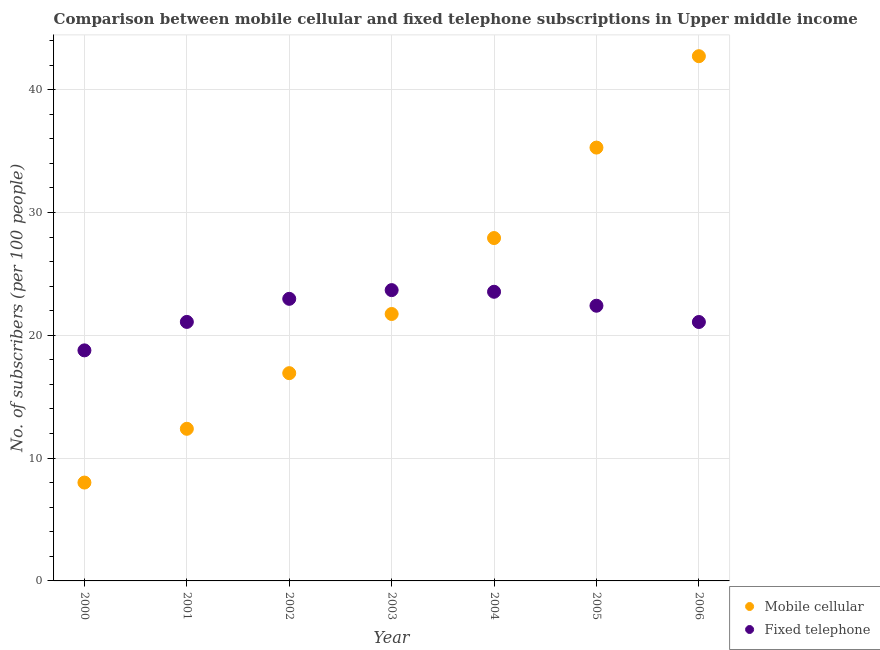How many different coloured dotlines are there?
Offer a terse response. 2. What is the number of mobile cellular subscribers in 2002?
Give a very brief answer. 16.92. Across all years, what is the maximum number of mobile cellular subscribers?
Keep it short and to the point. 42.73. Across all years, what is the minimum number of fixed telephone subscribers?
Give a very brief answer. 18.77. What is the total number of mobile cellular subscribers in the graph?
Provide a succinct answer. 164.99. What is the difference between the number of fixed telephone subscribers in 2003 and that in 2005?
Keep it short and to the point. 1.27. What is the difference between the number of fixed telephone subscribers in 2003 and the number of mobile cellular subscribers in 2000?
Provide a short and direct response. 15.67. What is the average number of fixed telephone subscribers per year?
Provide a succinct answer. 21.94. In the year 2000, what is the difference between the number of fixed telephone subscribers and number of mobile cellular subscribers?
Provide a succinct answer. 10.76. What is the ratio of the number of mobile cellular subscribers in 2001 to that in 2006?
Ensure brevity in your answer.  0.29. Is the number of fixed telephone subscribers in 2003 less than that in 2005?
Your response must be concise. No. What is the difference between the highest and the second highest number of fixed telephone subscribers?
Ensure brevity in your answer.  0.13. What is the difference between the highest and the lowest number of mobile cellular subscribers?
Offer a terse response. 34.72. Does the number of fixed telephone subscribers monotonically increase over the years?
Offer a very short reply. No. Is the number of mobile cellular subscribers strictly less than the number of fixed telephone subscribers over the years?
Keep it short and to the point. No. How many dotlines are there?
Your response must be concise. 2. What is the title of the graph?
Offer a very short reply. Comparison between mobile cellular and fixed telephone subscriptions in Upper middle income. Does "Under-five" appear as one of the legend labels in the graph?
Keep it short and to the point. No. What is the label or title of the X-axis?
Offer a terse response. Year. What is the label or title of the Y-axis?
Give a very brief answer. No. of subscribers (per 100 people). What is the No. of subscribers (per 100 people) in Mobile cellular in 2000?
Provide a short and direct response. 8.01. What is the No. of subscribers (per 100 people) of Fixed telephone in 2000?
Ensure brevity in your answer.  18.77. What is the No. of subscribers (per 100 people) in Mobile cellular in 2001?
Keep it short and to the point. 12.39. What is the No. of subscribers (per 100 people) in Fixed telephone in 2001?
Keep it short and to the point. 21.09. What is the No. of subscribers (per 100 people) of Mobile cellular in 2002?
Ensure brevity in your answer.  16.92. What is the No. of subscribers (per 100 people) in Fixed telephone in 2002?
Make the answer very short. 22.97. What is the No. of subscribers (per 100 people) of Mobile cellular in 2003?
Keep it short and to the point. 21.74. What is the No. of subscribers (per 100 people) of Fixed telephone in 2003?
Your response must be concise. 23.68. What is the No. of subscribers (per 100 people) in Mobile cellular in 2004?
Your response must be concise. 27.92. What is the No. of subscribers (per 100 people) in Fixed telephone in 2004?
Your answer should be compact. 23.55. What is the No. of subscribers (per 100 people) in Mobile cellular in 2005?
Ensure brevity in your answer.  35.29. What is the No. of subscribers (per 100 people) of Fixed telephone in 2005?
Make the answer very short. 22.41. What is the No. of subscribers (per 100 people) in Mobile cellular in 2006?
Provide a short and direct response. 42.73. What is the No. of subscribers (per 100 people) of Fixed telephone in 2006?
Your answer should be compact. 21.08. Across all years, what is the maximum No. of subscribers (per 100 people) in Mobile cellular?
Make the answer very short. 42.73. Across all years, what is the maximum No. of subscribers (per 100 people) in Fixed telephone?
Your answer should be very brief. 23.68. Across all years, what is the minimum No. of subscribers (per 100 people) of Mobile cellular?
Ensure brevity in your answer.  8.01. Across all years, what is the minimum No. of subscribers (per 100 people) in Fixed telephone?
Offer a very short reply. 18.77. What is the total No. of subscribers (per 100 people) of Mobile cellular in the graph?
Your answer should be very brief. 164.99. What is the total No. of subscribers (per 100 people) of Fixed telephone in the graph?
Provide a short and direct response. 153.56. What is the difference between the No. of subscribers (per 100 people) of Mobile cellular in 2000 and that in 2001?
Offer a very short reply. -4.38. What is the difference between the No. of subscribers (per 100 people) of Fixed telephone in 2000 and that in 2001?
Give a very brief answer. -2.32. What is the difference between the No. of subscribers (per 100 people) of Mobile cellular in 2000 and that in 2002?
Ensure brevity in your answer.  -8.91. What is the difference between the No. of subscribers (per 100 people) of Fixed telephone in 2000 and that in 2002?
Keep it short and to the point. -4.2. What is the difference between the No. of subscribers (per 100 people) in Mobile cellular in 2000 and that in 2003?
Provide a short and direct response. -13.73. What is the difference between the No. of subscribers (per 100 people) of Fixed telephone in 2000 and that in 2003?
Your response must be concise. -4.91. What is the difference between the No. of subscribers (per 100 people) of Mobile cellular in 2000 and that in 2004?
Your response must be concise. -19.91. What is the difference between the No. of subscribers (per 100 people) in Fixed telephone in 2000 and that in 2004?
Your answer should be very brief. -4.77. What is the difference between the No. of subscribers (per 100 people) of Mobile cellular in 2000 and that in 2005?
Make the answer very short. -27.28. What is the difference between the No. of subscribers (per 100 people) in Fixed telephone in 2000 and that in 2005?
Offer a very short reply. -3.63. What is the difference between the No. of subscribers (per 100 people) in Mobile cellular in 2000 and that in 2006?
Make the answer very short. -34.72. What is the difference between the No. of subscribers (per 100 people) in Fixed telephone in 2000 and that in 2006?
Your answer should be compact. -2.31. What is the difference between the No. of subscribers (per 100 people) in Mobile cellular in 2001 and that in 2002?
Provide a succinct answer. -4.53. What is the difference between the No. of subscribers (per 100 people) in Fixed telephone in 2001 and that in 2002?
Your answer should be compact. -1.88. What is the difference between the No. of subscribers (per 100 people) in Mobile cellular in 2001 and that in 2003?
Give a very brief answer. -9.35. What is the difference between the No. of subscribers (per 100 people) of Fixed telephone in 2001 and that in 2003?
Ensure brevity in your answer.  -2.59. What is the difference between the No. of subscribers (per 100 people) in Mobile cellular in 2001 and that in 2004?
Provide a short and direct response. -15.53. What is the difference between the No. of subscribers (per 100 people) of Fixed telephone in 2001 and that in 2004?
Give a very brief answer. -2.45. What is the difference between the No. of subscribers (per 100 people) in Mobile cellular in 2001 and that in 2005?
Provide a succinct answer. -22.9. What is the difference between the No. of subscribers (per 100 people) of Fixed telephone in 2001 and that in 2005?
Your answer should be compact. -1.32. What is the difference between the No. of subscribers (per 100 people) in Mobile cellular in 2001 and that in 2006?
Give a very brief answer. -30.34. What is the difference between the No. of subscribers (per 100 people) in Fixed telephone in 2001 and that in 2006?
Offer a terse response. 0.01. What is the difference between the No. of subscribers (per 100 people) in Mobile cellular in 2002 and that in 2003?
Make the answer very short. -4.82. What is the difference between the No. of subscribers (per 100 people) of Fixed telephone in 2002 and that in 2003?
Offer a very short reply. -0.71. What is the difference between the No. of subscribers (per 100 people) of Mobile cellular in 2002 and that in 2004?
Offer a very short reply. -11. What is the difference between the No. of subscribers (per 100 people) in Fixed telephone in 2002 and that in 2004?
Your answer should be very brief. -0.58. What is the difference between the No. of subscribers (per 100 people) in Mobile cellular in 2002 and that in 2005?
Keep it short and to the point. -18.37. What is the difference between the No. of subscribers (per 100 people) of Fixed telephone in 2002 and that in 2005?
Make the answer very short. 0.56. What is the difference between the No. of subscribers (per 100 people) in Mobile cellular in 2002 and that in 2006?
Provide a short and direct response. -25.81. What is the difference between the No. of subscribers (per 100 people) of Fixed telephone in 2002 and that in 2006?
Make the answer very short. 1.89. What is the difference between the No. of subscribers (per 100 people) in Mobile cellular in 2003 and that in 2004?
Ensure brevity in your answer.  -6.18. What is the difference between the No. of subscribers (per 100 people) of Fixed telephone in 2003 and that in 2004?
Keep it short and to the point. 0.13. What is the difference between the No. of subscribers (per 100 people) in Mobile cellular in 2003 and that in 2005?
Keep it short and to the point. -13.55. What is the difference between the No. of subscribers (per 100 people) in Fixed telephone in 2003 and that in 2005?
Offer a terse response. 1.27. What is the difference between the No. of subscribers (per 100 people) of Mobile cellular in 2003 and that in 2006?
Offer a terse response. -20.99. What is the difference between the No. of subscribers (per 100 people) of Fixed telephone in 2003 and that in 2006?
Your answer should be very brief. 2.6. What is the difference between the No. of subscribers (per 100 people) of Mobile cellular in 2004 and that in 2005?
Your answer should be very brief. -7.37. What is the difference between the No. of subscribers (per 100 people) in Fixed telephone in 2004 and that in 2005?
Your answer should be compact. 1.14. What is the difference between the No. of subscribers (per 100 people) in Mobile cellular in 2004 and that in 2006?
Provide a short and direct response. -14.81. What is the difference between the No. of subscribers (per 100 people) in Fixed telephone in 2004 and that in 2006?
Offer a very short reply. 2.46. What is the difference between the No. of subscribers (per 100 people) of Mobile cellular in 2005 and that in 2006?
Give a very brief answer. -7.44. What is the difference between the No. of subscribers (per 100 people) of Fixed telephone in 2005 and that in 2006?
Your answer should be compact. 1.32. What is the difference between the No. of subscribers (per 100 people) in Mobile cellular in 2000 and the No. of subscribers (per 100 people) in Fixed telephone in 2001?
Make the answer very short. -13.08. What is the difference between the No. of subscribers (per 100 people) of Mobile cellular in 2000 and the No. of subscribers (per 100 people) of Fixed telephone in 2002?
Your response must be concise. -14.96. What is the difference between the No. of subscribers (per 100 people) of Mobile cellular in 2000 and the No. of subscribers (per 100 people) of Fixed telephone in 2003?
Give a very brief answer. -15.67. What is the difference between the No. of subscribers (per 100 people) of Mobile cellular in 2000 and the No. of subscribers (per 100 people) of Fixed telephone in 2004?
Your answer should be very brief. -15.54. What is the difference between the No. of subscribers (per 100 people) in Mobile cellular in 2000 and the No. of subscribers (per 100 people) in Fixed telephone in 2005?
Your answer should be compact. -14.4. What is the difference between the No. of subscribers (per 100 people) of Mobile cellular in 2000 and the No. of subscribers (per 100 people) of Fixed telephone in 2006?
Provide a short and direct response. -13.07. What is the difference between the No. of subscribers (per 100 people) in Mobile cellular in 2001 and the No. of subscribers (per 100 people) in Fixed telephone in 2002?
Give a very brief answer. -10.58. What is the difference between the No. of subscribers (per 100 people) in Mobile cellular in 2001 and the No. of subscribers (per 100 people) in Fixed telephone in 2003?
Ensure brevity in your answer.  -11.29. What is the difference between the No. of subscribers (per 100 people) of Mobile cellular in 2001 and the No. of subscribers (per 100 people) of Fixed telephone in 2004?
Provide a short and direct response. -11.16. What is the difference between the No. of subscribers (per 100 people) of Mobile cellular in 2001 and the No. of subscribers (per 100 people) of Fixed telephone in 2005?
Ensure brevity in your answer.  -10.02. What is the difference between the No. of subscribers (per 100 people) of Mobile cellular in 2001 and the No. of subscribers (per 100 people) of Fixed telephone in 2006?
Ensure brevity in your answer.  -8.7. What is the difference between the No. of subscribers (per 100 people) in Mobile cellular in 2002 and the No. of subscribers (per 100 people) in Fixed telephone in 2003?
Your answer should be compact. -6.76. What is the difference between the No. of subscribers (per 100 people) in Mobile cellular in 2002 and the No. of subscribers (per 100 people) in Fixed telephone in 2004?
Your answer should be very brief. -6.63. What is the difference between the No. of subscribers (per 100 people) in Mobile cellular in 2002 and the No. of subscribers (per 100 people) in Fixed telephone in 2005?
Provide a short and direct response. -5.49. What is the difference between the No. of subscribers (per 100 people) of Mobile cellular in 2002 and the No. of subscribers (per 100 people) of Fixed telephone in 2006?
Provide a succinct answer. -4.17. What is the difference between the No. of subscribers (per 100 people) of Mobile cellular in 2003 and the No. of subscribers (per 100 people) of Fixed telephone in 2004?
Your answer should be compact. -1.81. What is the difference between the No. of subscribers (per 100 people) of Mobile cellular in 2003 and the No. of subscribers (per 100 people) of Fixed telephone in 2005?
Offer a terse response. -0.67. What is the difference between the No. of subscribers (per 100 people) in Mobile cellular in 2003 and the No. of subscribers (per 100 people) in Fixed telephone in 2006?
Provide a short and direct response. 0.65. What is the difference between the No. of subscribers (per 100 people) of Mobile cellular in 2004 and the No. of subscribers (per 100 people) of Fixed telephone in 2005?
Provide a succinct answer. 5.51. What is the difference between the No. of subscribers (per 100 people) of Mobile cellular in 2004 and the No. of subscribers (per 100 people) of Fixed telephone in 2006?
Give a very brief answer. 6.84. What is the difference between the No. of subscribers (per 100 people) in Mobile cellular in 2005 and the No. of subscribers (per 100 people) in Fixed telephone in 2006?
Keep it short and to the point. 14.2. What is the average No. of subscribers (per 100 people) of Mobile cellular per year?
Give a very brief answer. 23.57. What is the average No. of subscribers (per 100 people) in Fixed telephone per year?
Provide a short and direct response. 21.94. In the year 2000, what is the difference between the No. of subscribers (per 100 people) in Mobile cellular and No. of subscribers (per 100 people) in Fixed telephone?
Offer a very short reply. -10.77. In the year 2001, what is the difference between the No. of subscribers (per 100 people) of Mobile cellular and No. of subscribers (per 100 people) of Fixed telephone?
Provide a short and direct response. -8.7. In the year 2002, what is the difference between the No. of subscribers (per 100 people) in Mobile cellular and No. of subscribers (per 100 people) in Fixed telephone?
Offer a terse response. -6.05. In the year 2003, what is the difference between the No. of subscribers (per 100 people) of Mobile cellular and No. of subscribers (per 100 people) of Fixed telephone?
Your response must be concise. -1.94. In the year 2004, what is the difference between the No. of subscribers (per 100 people) in Mobile cellular and No. of subscribers (per 100 people) in Fixed telephone?
Your response must be concise. 4.37. In the year 2005, what is the difference between the No. of subscribers (per 100 people) in Mobile cellular and No. of subscribers (per 100 people) in Fixed telephone?
Keep it short and to the point. 12.88. In the year 2006, what is the difference between the No. of subscribers (per 100 people) in Mobile cellular and No. of subscribers (per 100 people) in Fixed telephone?
Your answer should be compact. 21.65. What is the ratio of the No. of subscribers (per 100 people) in Mobile cellular in 2000 to that in 2001?
Ensure brevity in your answer.  0.65. What is the ratio of the No. of subscribers (per 100 people) of Fixed telephone in 2000 to that in 2001?
Make the answer very short. 0.89. What is the ratio of the No. of subscribers (per 100 people) in Mobile cellular in 2000 to that in 2002?
Provide a short and direct response. 0.47. What is the ratio of the No. of subscribers (per 100 people) of Fixed telephone in 2000 to that in 2002?
Offer a terse response. 0.82. What is the ratio of the No. of subscribers (per 100 people) in Mobile cellular in 2000 to that in 2003?
Make the answer very short. 0.37. What is the ratio of the No. of subscribers (per 100 people) in Fixed telephone in 2000 to that in 2003?
Keep it short and to the point. 0.79. What is the ratio of the No. of subscribers (per 100 people) of Mobile cellular in 2000 to that in 2004?
Your response must be concise. 0.29. What is the ratio of the No. of subscribers (per 100 people) of Fixed telephone in 2000 to that in 2004?
Your answer should be compact. 0.8. What is the ratio of the No. of subscribers (per 100 people) of Mobile cellular in 2000 to that in 2005?
Give a very brief answer. 0.23. What is the ratio of the No. of subscribers (per 100 people) in Fixed telephone in 2000 to that in 2005?
Offer a terse response. 0.84. What is the ratio of the No. of subscribers (per 100 people) of Mobile cellular in 2000 to that in 2006?
Provide a short and direct response. 0.19. What is the ratio of the No. of subscribers (per 100 people) in Fixed telephone in 2000 to that in 2006?
Provide a short and direct response. 0.89. What is the ratio of the No. of subscribers (per 100 people) of Mobile cellular in 2001 to that in 2002?
Offer a terse response. 0.73. What is the ratio of the No. of subscribers (per 100 people) in Fixed telephone in 2001 to that in 2002?
Your response must be concise. 0.92. What is the ratio of the No. of subscribers (per 100 people) of Mobile cellular in 2001 to that in 2003?
Your answer should be compact. 0.57. What is the ratio of the No. of subscribers (per 100 people) of Fixed telephone in 2001 to that in 2003?
Offer a terse response. 0.89. What is the ratio of the No. of subscribers (per 100 people) in Mobile cellular in 2001 to that in 2004?
Keep it short and to the point. 0.44. What is the ratio of the No. of subscribers (per 100 people) of Fixed telephone in 2001 to that in 2004?
Ensure brevity in your answer.  0.9. What is the ratio of the No. of subscribers (per 100 people) of Mobile cellular in 2001 to that in 2005?
Your answer should be compact. 0.35. What is the ratio of the No. of subscribers (per 100 people) in Mobile cellular in 2001 to that in 2006?
Make the answer very short. 0.29. What is the ratio of the No. of subscribers (per 100 people) of Fixed telephone in 2001 to that in 2006?
Your answer should be very brief. 1. What is the ratio of the No. of subscribers (per 100 people) of Mobile cellular in 2002 to that in 2003?
Your answer should be very brief. 0.78. What is the ratio of the No. of subscribers (per 100 people) in Fixed telephone in 2002 to that in 2003?
Your answer should be compact. 0.97. What is the ratio of the No. of subscribers (per 100 people) in Mobile cellular in 2002 to that in 2004?
Your answer should be compact. 0.61. What is the ratio of the No. of subscribers (per 100 people) in Fixed telephone in 2002 to that in 2004?
Your response must be concise. 0.98. What is the ratio of the No. of subscribers (per 100 people) of Mobile cellular in 2002 to that in 2005?
Your response must be concise. 0.48. What is the ratio of the No. of subscribers (per 100 people) of Fixed telephone in 2002 to that in 2005?
Give a very brief answer. 1.03. What is the ratio of the No. of subscribers (per 100 people) in Mobile cellular in 2002 to that in 2006?
Give a very brief answer. 0.4. What is the ratio of the No. of subscribers (per 100 people) in Fixed telephone in 2002 to that in 2006?
Give a very brief answer. 1.09. What is the ratio of the No. of subscribers (per 100 people) in Mobile cellular in 2003 to that in 2004?
Provide a succinct answer. 0.78. What is the ratio of the No. of subscribers (per 100 people) in Fixed telephone in 2003 to that in 2004?
Your answer should be very brief. 1.01. What is the ratio of the No. of subscribers (per 100 people) of Mobile cellular in 2003 to that in 2005?
Ensure brevity in your answer.  0.62. What is the ratio of the No. of subscribers (per 100 people) of Fixed telephone in 2003 to that in 2005?
Ensure brevity in your answer.  1.06. What is the ratio of the No. of subscribers (per 100 people) of Mobile cellular in 2003 to that in 2006?
Provide a short and direct response. 0.51. What is the ratio of the No. of subscribers (per 100 people) in Fixed telephone in 2003 to that in 2006?
Your response must be concise. 1.12. What is the ratio of the No. of subscribers (per 100 people) of Mobile cellular in 2004 to that in 2005?
Make the answer very short. 0.79. What is the ratio of the No. of subscribers (per 100 people) of Fixed telephone in 2004 to that in 2005?
Your response must be concise. 1.05. What is the ratio of the No. of subscribers (per 100 people) of Mobile cellular in 2004 to that in 2006?
Provide a succinct answer. 0.65. What is the ratio of the No. of subscribers (per 100 people) of Fixed telephone in 2004 to that in 2006?
Keep it short and to the point. 1.12. What is the ratio of the No. of subscribers (per 100 people) of Mobile cellular in 2005 to that in 2006?
Make the answer very short. 0.83. What is the ratio of the No. of subscribers (per 100 people) of Fixed telephone in 2005 to that in 2006?
Your answer should be compact. 1.06. What is the difference between the highest and the second highest No. of subscribers (per 100 people) of Mobile cellular?
Your answer should be compact. 7.44. What is the difference between the highest and the second highest No. of subscribers (per 100 people) of Fixed telephone?
Your answer should be compact. 0.13. What is the difference between the highest and the lowest No. of subscribers (per 100 people) in Mobile cellular?
Make the answer very short. 34.72. What is the difference between the highest and the lowest No. of subscribers (per 100 people) in Fixed telephone?
Your answer should be very brief. 4.91. 